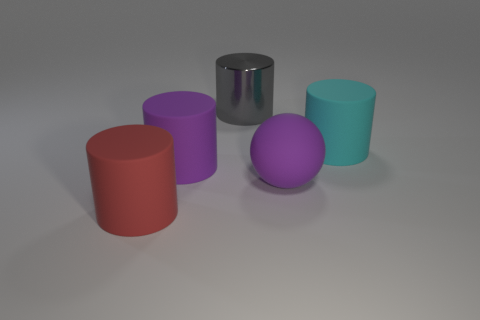Which object stands out the most, and why? The silver cylinder stands out the most due to its reflective surface, which contrasts with the matte finishes of the other objects. Its bright and shiny appearance attracts the eye amidst the more subdued colors and textures in the image. 